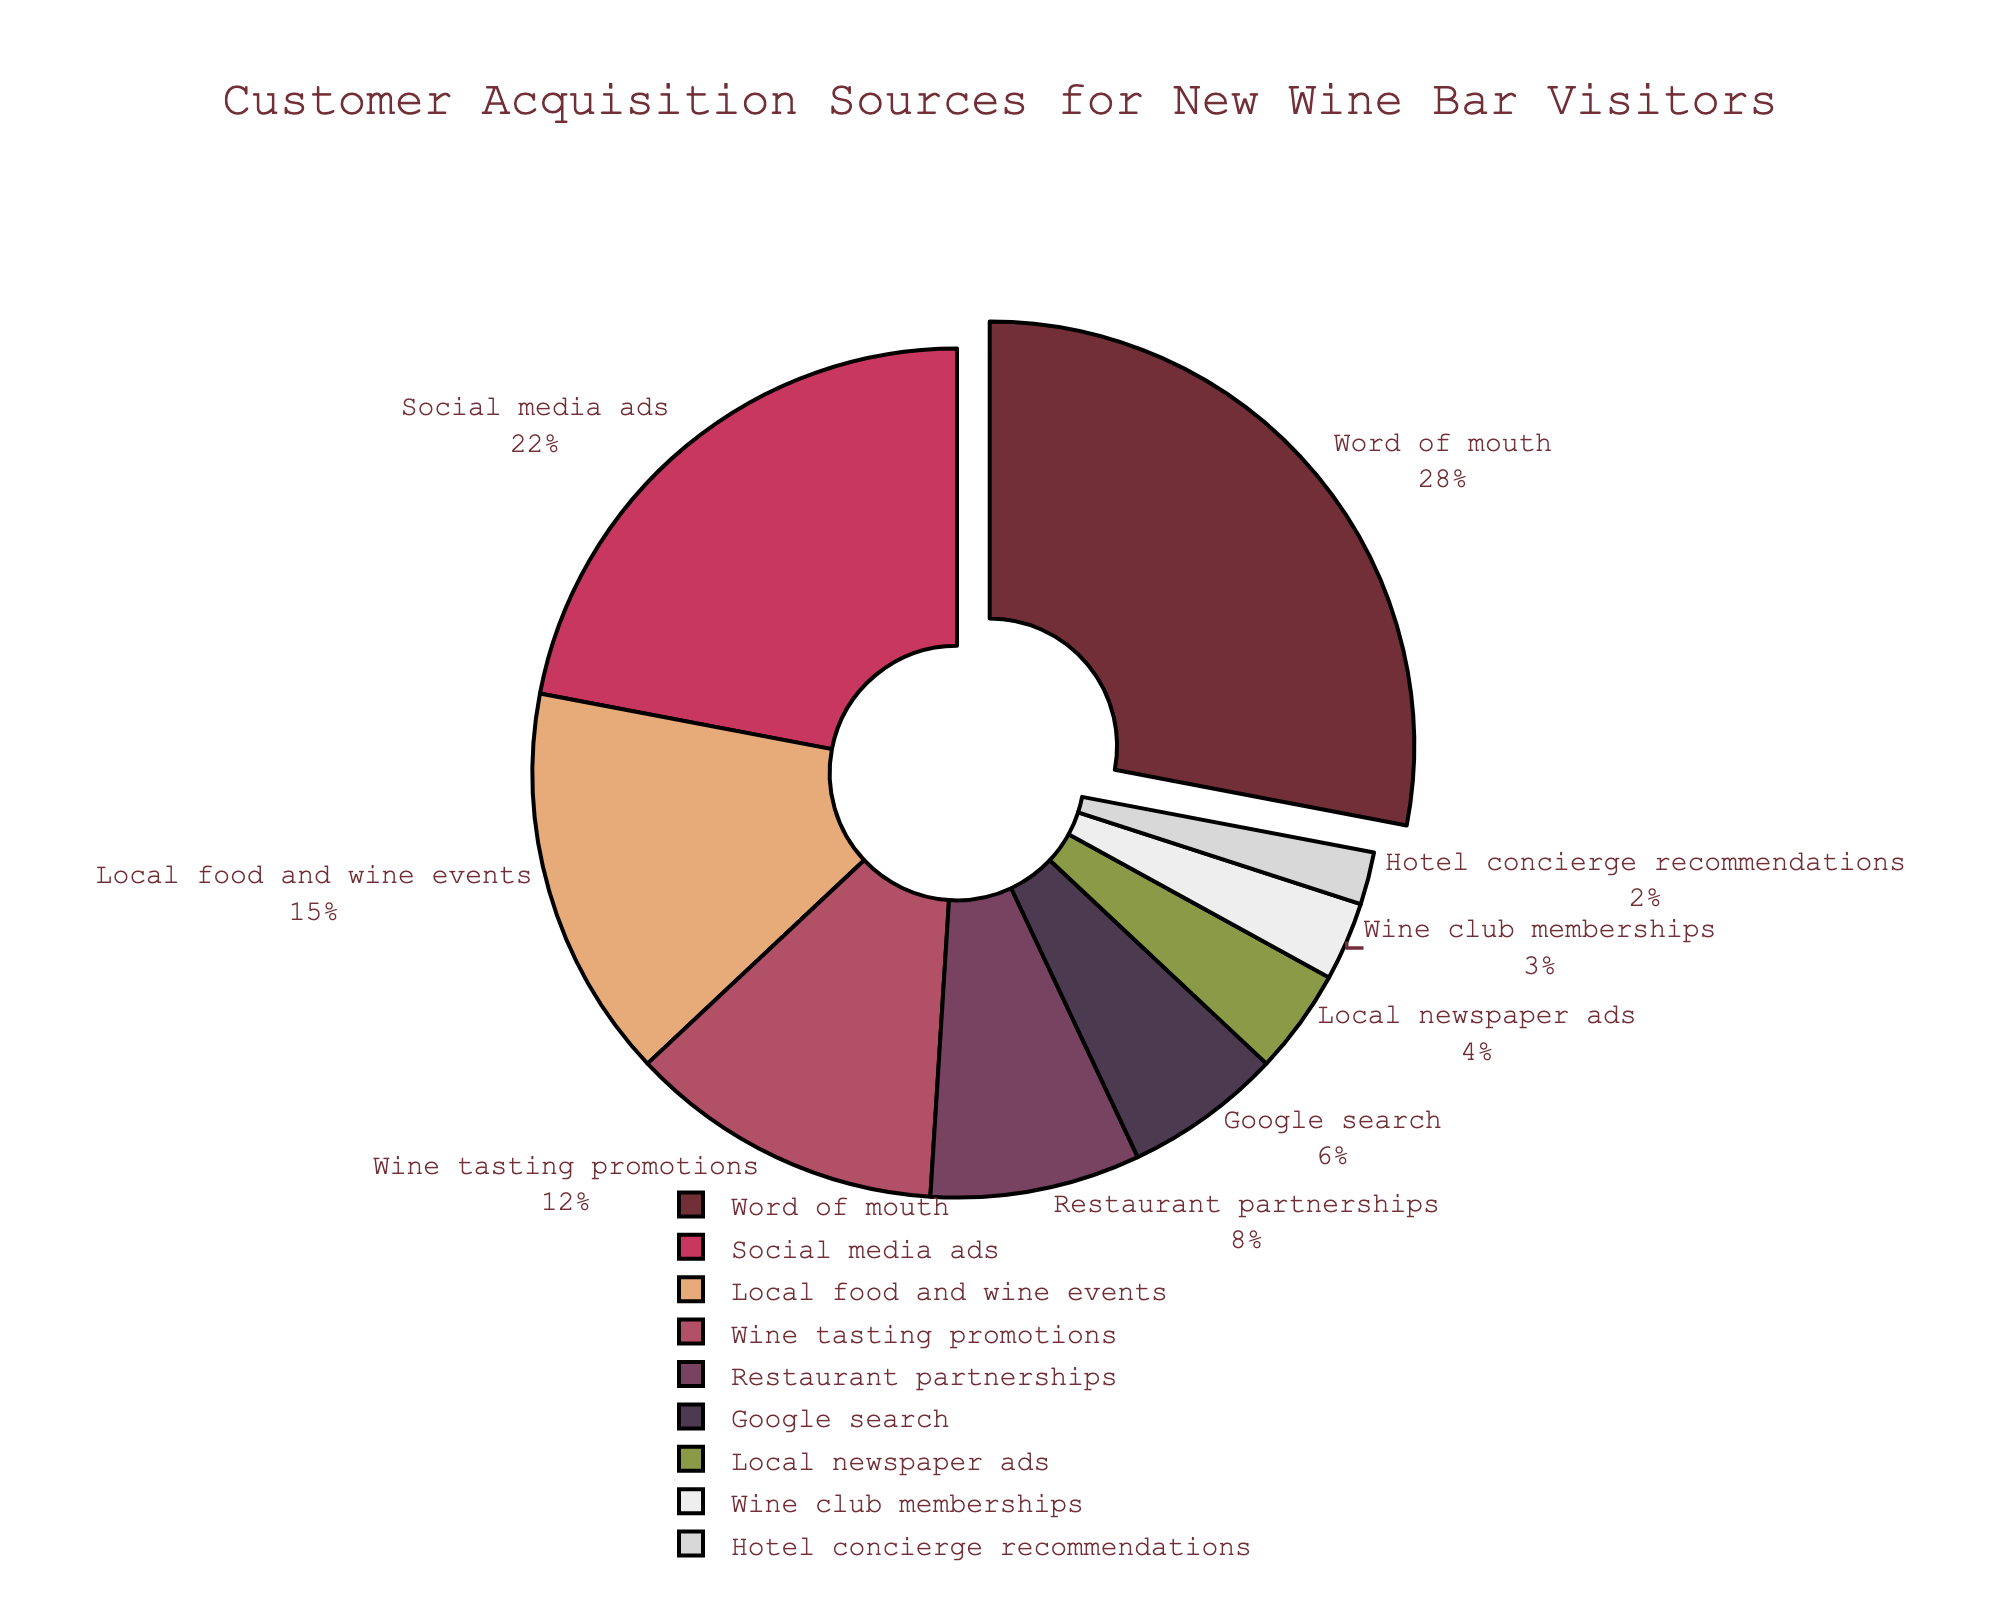What is the most common source of customer acquisition? The most common source corresponds to the largest segment of the pie chart, which is labeled "Word of mouth" taking up 28% of the pie.
Answer: Word of mouth Which customer acquisition source has the smallest percentage? The smallest segment in the pie chart is labeled "Hotel concierge recommendations," which accounts for 2% of the acquisition sources.
Answer: Hotel concierge recommendations What percentage of visitors come from 'Word of mouth' and 'Social media ads' combined? Add the percentages of "Word of mouth" (28%) and "Social media ads" (22%) from the chart: 28% + 22% = 50%.
Answer: 50% Is Google search a more significant acquisition source than Local newspaper ads? Compare the percentages of "Google search" (6%) and "Local newspaper ads" (4%) from the pie chart: 6% is greater than 4%.
Answer: Yes Which source, 'Local food and wine events' or 'Wine tasting promotions', contributes more to customer acquisition? Check the pie chart segments for both sources: "Local food and wine events" (15%) and "Wine tasting promotions" (12%). 15% is larger than 12%.
Answer: Local food and wine events What is the combined percentage of customers from Wine club memberships, Restaurant partnerships, and Local newspaper ads? Sum the percentages of "Wine club memberships" (3%), "Restaurant partnerships" (8%), and "Local newspaper ads" (4%): 3% + 8% + 4% = 15%.
Answer: 15% Which source has a higher percentage, Google search or Wine tasting promotions? Compare the percentages: Google search (6%) and Wine tasting promotions (12%). 12% is greater than 6%.
Answer: Wine tasting promotions What percentage of customers come from Restaurant partnerships and Wine club memberships combined? Add the percentages of "Restaurant partnerships" (8%) and "Wine club memberships" (3%): 8% + 3% = 11%.
Answer: 11% What are the top three customer acquisition sources according to the pie chart? Identify the segments with the largest percentages: "Word of mouth" (28%), "Social media ads" (22%), and "Local food and wine events" (15%) appear to be the top three.
Answer: Word of mouth, Social media ads, Local food and wine events What is the difference in percentage points between Word of mouth and Google search? Calculate the difference between the percentages of "Word of mouth" (28%) and "Google search" (6%): 28% - 6% = 22 percentage points.
Answer: 22 percentage points 